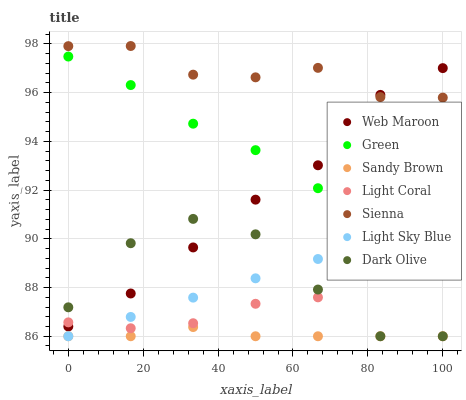Does Sandy Brown have the minimum area under the curve?
Answer yes or no. Yes. Does Sienna have the maximum area under the curve?
Answer yes or no. Yes. Does Dark Olive have the minimum area under the curve?
Answer yes or no. No. Does Dark Olive have the maximum area under the curve?
Answer yes or no. No. Is Light Sky Blue the smoothest?
Answer yes or no. Yes. Is Dark Olive the roughest?
Answer yes or no. Yes. Is Web Maroon the smoothest?
Answer yes or no. No. Is Web Maroon the roughest?
Answer yes or no. No. Does Dark Olive have the lowest value?
Answer yes or no. Yes. Does Web Maroon have the lowest value?
Answer yes or no. No. Does Sienna have the highest value?
Answer yes or no. Yes. Does Dark Olive have the highest value?
Answer yes or no. No. Is Light Sky Blue less than Sienna?
Answer yes or no. Yes. Is Sienna greater than Light Sky Blue?
Answer yes or no. Yes. Does Light Coral intersect Web Maroon?
Answer yes or no. Yes. Is Light Coral less than Web Maroon?
Answer yes or no. No. Is Light Coral greater than Web Maroon?
Answer yes or no. No. Does Light Sky Blue intersect Sienna?
Answer yes or no. No. 